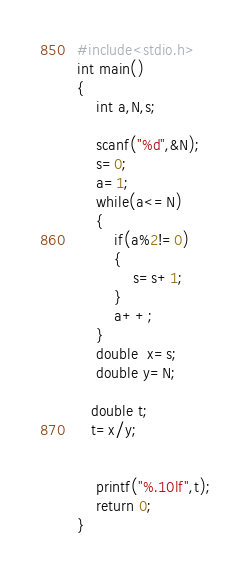<code> <loc_0><loc_0><loc_500><loc_500><_C_>#include<stdio.h>
int main()
{
    int a,N,s;

    scanf("%d",&N);
    s=0;
    a=1;
    while(a<=N)
    {
        if(a%2!=0)
        {
            s=s+1;
        }
        a++;
    }
    double  x=s;
    double y=N;

   double t;
   t=x/y;


    printf("%.10lf",t);
    return 0;
}
</code> 